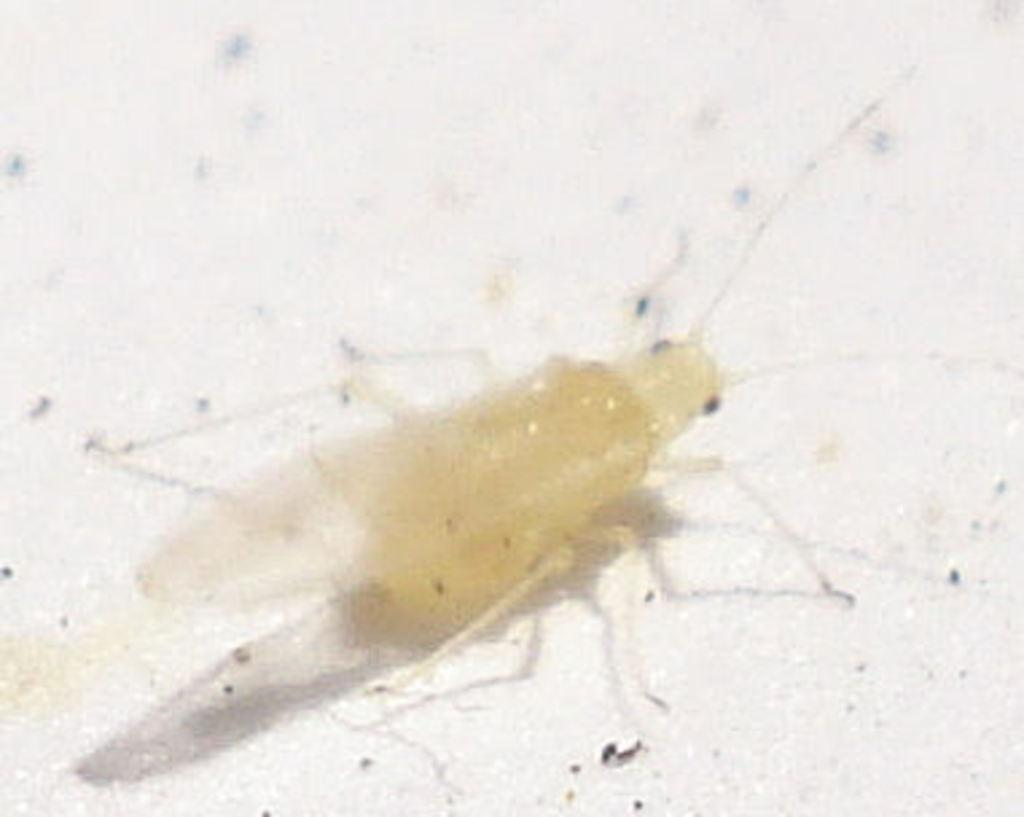What is the main subject of the image? There is an insect in the center of the image. What type of wheel can be seen attached to the insect in the image? There is no wheel present in the image, and the insect is not attached to any wheel. 